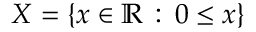Convert formula to latex. <formula><loc_0><loc_0><loc_500><loc_500>X = \{ x \in \mathbb { R } \, \colon \, 0 \leq x \}</formula> 